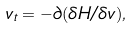Convert formula to latex. <formula><loc_0><loc_0><loc_500><loc_500>v _ { t } = - \partial ( \delta H / \delta v ) ,</formula> 